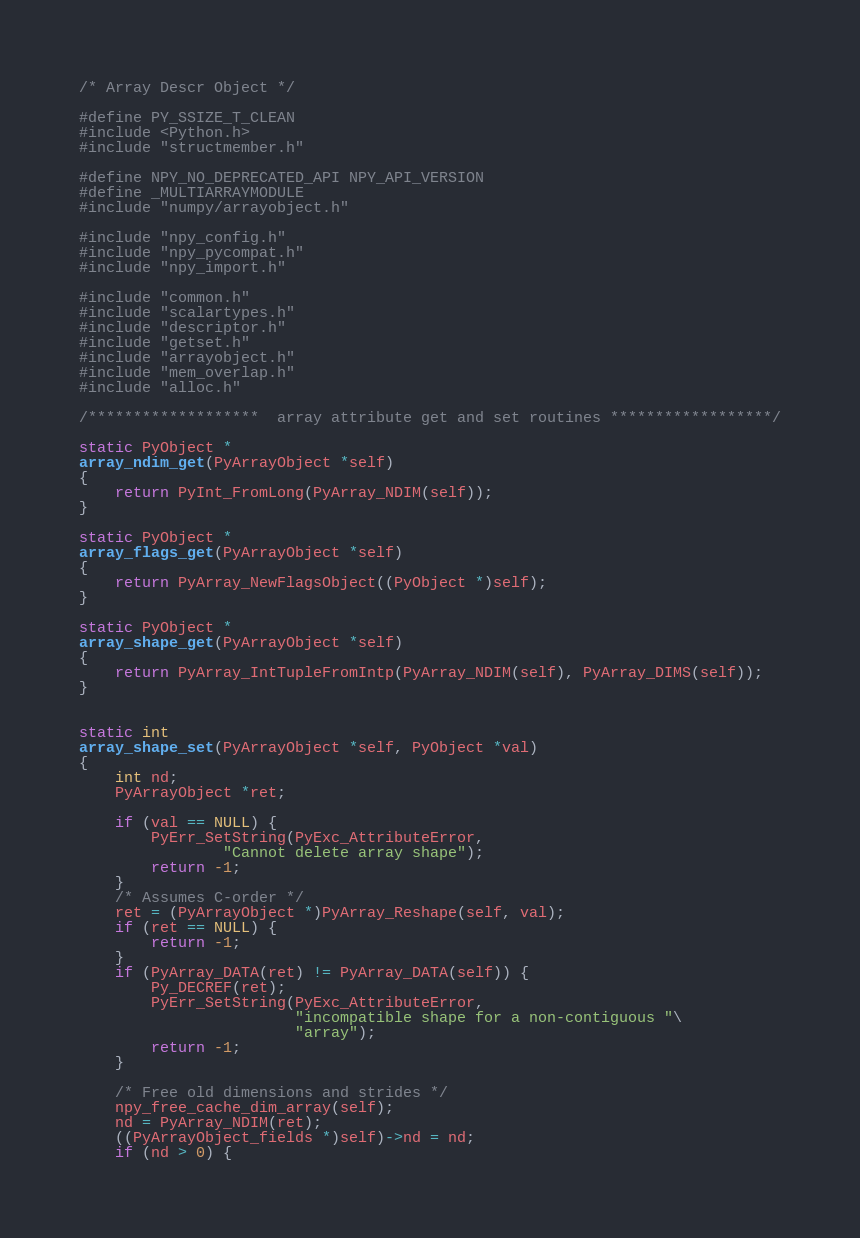Convert code to text. <code><loc_0><loc_0><loc_500><loc_500><_C_>/* Array Descr Object */

#define PY_SSIZE_T_CLEAN
#include <Python.h>
#include "structmember.h"

#define NPY_NO_DEPRECATED_API NPY_API_VERSION
#define _MULTIARRAYMODULE
#include "numpy/arrayobject.h"

#include "npy_config.h"
#include "npy_pycompat.h"
#include "npy_import.h"

#include "common.h"
#include "scalartypes.h"
#include "descriptor.h"
#include "getset.h"
#include "arrayobject.h"
#include "mem_overlap.h"
#include "alloc.h"

/*******************  array attribute get and set routines ******************/

static PyObject *
array_ndim_get(PyArrayObject *self)
{
    return PyInt_FromLong(PyArray_NDIM(self));
}

static PyObject *
array_flags_get(PyArrayObject *self)
{
    return PyArray_NewFlagsObject((PyObject *)self);
}

static PyObject *
array_shape_get(PyArrayObject *self)
{
    return PyArray_IntTupleFromIntp(PyArray_NDIM(self), PyArray_DIMS(self));
}


static int
array_shape_set(PyArrayObject *self, PyObject *val)
{
    int nd;
    PyArrayObject *ret;

    if (val == NULL) {
        PyErr_SetString(PyExc_AttributeError,
                "Cannot delete array shape");
        return -1;
    }
    /* Assumes C-order */
    ret = (PyArrayObject *)PyArray_Reshape(self, val);
    if (ret == NULL) {
        return -1;
    }
    if (PyArray_DATA(ret) != PyArray_DATA(self)) {
        Py_DECREF(ret);
        PyErr_SetString(PyExc_AttributeError,
                        "incompatible shape for a non-contiguous "\
                        "array");
        return -1;
    }

    /* Free old dimensions and strides */
    npy_free_cache_dim_array(self);
    nd = PyArray_NDIM(ret);
    ((PyArrayObject_fields *)self)->nd = nd;
    if (nd > 0) {</code> 